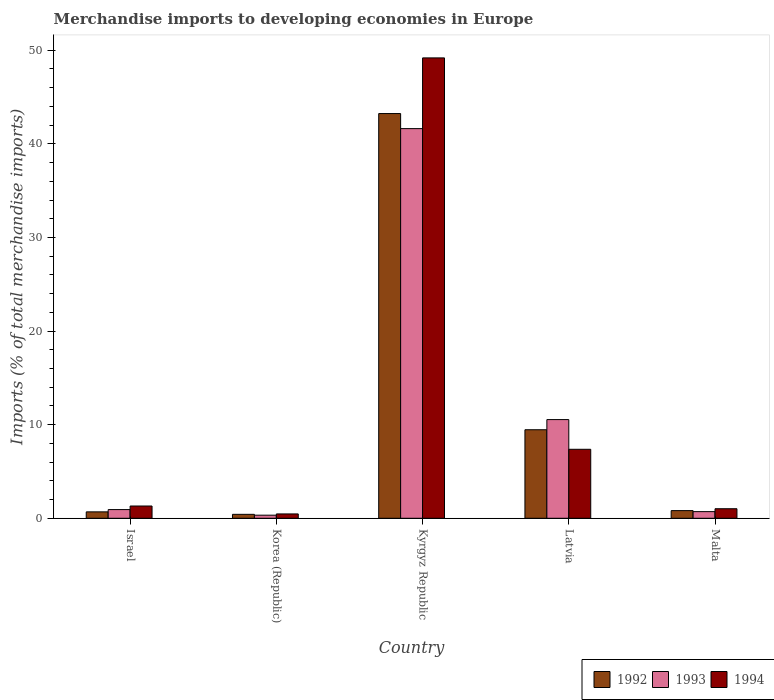How many different coloured bars are there?
Provide a short and direct response. 3. Are the number of bars per tick equal to the number of legend labels?
Your response must be concise. Yes. Are the number of bars on each tick of the X-axis equal?
Offer a terse response. Yes. How many bars are there on the 5th tick from the right?
Your answer should be very brief. 3. What is the label of the 3rd group of bars from the left?
Offer a very short reply. Kyrgyz Republic. What is the percentage total merchandise imports in 1993 in Kyrgyz Republic?
Offer a terse response. 41.63. Across all countries, what is the maximum percentage total merchandise imports in 1994?
Your answer should be very brief. 49.18. Across all countries, what is the minimum percentage total merchandise imports in 1994?
Ensure brevity in your answer.  0.46. In which country was the percentage total merchandise imports in 1994 maximum?
Ensure brevity in your answer.  Kyrgyz Republic. In which country was the percentage total merchandise imports in 1994 minimum?
Provide a short and direct response. Korea (Republic). What is the total percentage total merchandise imports in 1993 in the graph?
Ensure brevity in your answer.  54.14. What is the difference between the percentage total merchandise imports in 1993 in Korea (Republic) and that in Malta?
Offer a terse response. -0.38. What is the difference between the percentage total merchandise imports in 1994 in Malta and the percentage total merchandise imports in 1993 in Kyrgyz Republic?
Offer a terse response. -40.61. What is the average percentage total merchandise imports in 1992 per country?
Ensure brevity in your answer.  10.92. What is the difference between the percentage total merchandise imports of/in 1992 and percentage total merchandise imports of/in 1994 in Malta?
Make the answer very short. -0.2. What is the ratio of the percentage total merchandise imports in 1993 in Kyrgyz Republic to that in Latvia?
Your answer should be compact. 3.95. Is the difference between the percentage total merchandise imports in 1992 in Israel and Latvia greater than the difference between the percentage total merchandise imports in 1994 in Israel and Latvia?
Your response must be concise. No. What is the difference between the highest and the second highest percentage total merchandise imports in 1994?
Keep it short and to the point. 47.87. What is the difference between the highest and the lowest percentage total merchandise imports in 1992?
Offer a very short reply. 42.82. Is the sum of the percentage total merchandise imports in 1994 in Kyrgyz Republic and Latvia greater than the maximum percentage total merchandise imports in 1992 across all countries?
Offer a very short reply. Yes. What does the 3rd bar from the left in Latvia represents?
Make the answer very short. 1994. What does the 2nd bar from the right in Korea (Republic) represents?
Your response must be concise. 1993. Is it the case that in every country, the sum of the percentage total merchandise imports in 1994 and percentage total merchandise imports in 1992 is greater than the percentage total merchandise imports in 1993?
Provide a succinct answer. Yes. How many countries are there in the graph?
Keep it short and to the point. 5. What is the difference between two consecutive major ticks on the Y-axis?
Ensure brevity in your answer.  10. Does the graph contain any zero values?
Your answer should be compact. No. Does the graph contain grids?
Keep it short and to the point. No. How are the legend labels stacked?
Your response must be concise. Horizontal. What is the title of the graph?
Ensure brevity in your answer.  Merchandise imports to developing economies in Europe. Does "1967" appear as one of the legend labels in the graph?
Your answer should be compact. No. What is the label or title of the Y-axis?
Provide a succinct answer. Imports (% of total merchandise imports). What is the Imports (% of total merchandise imports) in 1992 in Israel?
Ensure brevity in your answer.  0.68. What is the Imports (% of total merchandise imports) in 1993 in Israel?
Offer a very short reply. 0.93. What is the Imports (% of total merchandise imports) in 1994 in Israel?
Your response must be concise. 1.31. What is the Imports (% of total merchandise imports) of 1992 in Korea (Republic)?
Keep it short and to the point. 0.42. What is the Imports (% of total merchandise imports) of 1993 in Korea (Republic)?
Your answer should be compact. 0.33. What is the Imports (% of total merchandise imports) of 1994 in Korea (Republic)?
Ensure brevity in your answer.  0.46. What is the Imports (% of total merchandise imports) of 1992 in Kyrgyz Republic?
Give a very brief answer. 43.24. What is the Imports (% of total merchandise imports) of 1993 in Kyrgyz Republic?
Provide a short and direct response. 41.63. What is the Imports (% of total merchandise imports) in 1994 in Kyrgyz Republic?
Keep it short and to the point. 49.18. What is the Imports (% of total merchandise imports) in 1992 in Latvia?
Make the answer very short. 9.46. What is the Imports (% of total merchandise imports) of 1993 in Latvia?
Your response must be concise. 10.54. What is the Imports (% of total merchandise imports) in 1994 in Latvia?
Ensure brevity in your answer.  7.37. What is the Imports (% of total merchandise imports) in 1992 in Malta?
Offer a very short reply. 0.82. What is the Imports (% of total merchandise imports) of 1993 in Malta?
Offer a terse response. 0.71. What is the Imports (% of total merchandise imports) of 1994 in Malta?
Provide a short and direct response. 1.02. Across all countries, what is the maximum Imports (% of total merchandise imports) of 1992?
Offer a very short reply. 43.24. Across all countries, what is the maximum Imports (% of total merchandise imports) in 1993?
Provide a succinct answer. 41.63. Across all countries, what is the maximum Imports (% of total merchandise imports) in 1994?
Provide a short and direct response. 49.18. Across all countries, what is the minimum Imports (% of total merchandise imports) in 1992?
Your answer should be compact. 0.42. Across all countries, what is the minimum Imports (% of total merchandise imports) in 1993?
Offer a terse response. 0.33. Across all countries, what is the minimum Imports (% of total merchandise imports) of 1994?
Keep it short and to the point. 0.46. What is the total Imports (% of total merchandise imports) in 1992 in the graph?
Provide a succinct answer. 54.62. What is the total Imports (% of total merchandise imports) of 1993 in the graph?
Offer a very short reply. 54.14. What is the total Imports (% of total merchandise imports) of 1994 in the graph?
Your answer should be compact. 59.35. What is the difference between the Imports (% of total merchandise imports) of 1992 in Israel and that in Korea (Republic)?
Offer a very short reply. 0.26. What is the difference between the Imports (% of total merchandise imports) in 1993 in Israel and that in Korea (Republic)?
Offer a very short reply. 0.6. What is the difference between the Imports (% of total merchandise imports) in 1994 in Israel and that in Korea (Republic)?
Provide a succinct answer. 0.85. What is the difference between the Imports (% of total merchandise imports) in 1992 in Israel and that in Kyrgyz Republic?
Your response must be concise. -42.55. What is the difference between the Imports (% of total merchandise imports) of 1993 in Israel and that in Kyrgyz Republic?
Your response must be concise. -40.7. What is the difference between the Imports (% of total merchandise imports) of 1994 in Israel and that in Kyrgyz Republic?
Offer a very short reply. -47.87. What is the difference between the Imports (% of total merchandise imports) of 1992 in Israel and that in Latvia?
Your answer should be very brief. -8.77. What is the difference between the Imports (% of total merchandise imports) in 1993 in Israel and that in Latvia?
Offer a very short reply. -9.62. What is the difference between the Imports (% of total merchandise imports) of 1994 in Israel and that in Latvia?
Keep it short and to the point. -6.06. What is the difference between the Imports (% of total merchandise imports) in 1992 in Israel and that in Malta?
Your answer should be very brief. -0.13. What is the difference between the Imports (% of total merchandise imports) of 1993 in Israel and that in Malta?
Your answer should be compact. 0.22. What is the difference between the Imports (% of total merchandise imports) of 1994 in Israel and that in Malta?
Provide a short and direct response. 0.29. What is the difference between the Imports (% of total merchandise imports) of 1992 in Korea (Republic) and that in Kyrgyz Republic?
Your answer should be compact. -42.82. What is the difference between the Imports (% of total merchandise imports) of 1993 in Korea (Republic) and that in Kyrgyz Republic?
Keep it short and to the point. -41.3. What is the difference between the Imports (% of total merchandise imports) of 1994 in Korea (Republic) and that in Kyrgyz Republic?
Your answer should be compact. -48.72. What is the difference between the Imports (% of total merchandise imports) of 1992 in Korea (Republic) and that in Latvia?
Your answer should be compact. -9.04. What is the difference between the Imports (% of total merchandise imports) of 1993 in Korea (Republic) and that in Latvia?
Offer a terse response. -10.21. What is the difference between the Imports (% of total merchandise imports) of 1994 in Korea (Republic) and that in Latvia?
Your response must be concise. -6.91. What is the difference between the Imports (% of total merchandise imports) in 1992 in Korea (Republic) and that in Malta?
Your response must be concise. -0.4. What is the difference between the Imports (% of total merchandise imports) in 1993 in Korea (Republic) and that in Malta?
Ensure brevity in your answer.  -0.38. What is the difference between the Imports (% of total merchandise imports) of 1994 in Korea (Republic) and that in Malta?
Give a very brief answer. -0.56. What is the difference between the Imports (% of total merchandise imports) in 1992 in Kyrgyz Republic and that in Latvia?
Your answer should be compact. 33.78. What is the difference between the Imports (% of total merchandise imports) of 1993 in Kyrgyz Republic and that in Latvia?
Offer a very short reply. 31.08. What is the difference between the Imports (% of total merchandise imports) in 1994 in Kyrgyz Republic and that in Latvia?
Offer a terse response. 41.81. What is the difference between the Imports (% of total merchandise imports) of 1992 in Kyrgyz Republic and that in Malta?
Give a very brief answer. 42.42. What is the difference between the Imports (% of total merchandise imports) of 1993 in Kyrgyz Republic and that in Malta?
Ensure brevity in your answer.  40.92. What is the difference between the Imports (% of total merchandise imports) in 1994 in Kyrgyz Republic and that in Malta?
Your answer should be very brief. 48.16. What is the difference between the Imports (% of total merchandise imports) in 1992 in Latvia and that in Malta?
Your response must be concise. 8.64. What is the difference between the Imports (% of total merchandise imports) of 1993 in Latvia and that in Malta?
Make the answer very short. 9.83. What is the difference between the Imports (% of total merchandise imports) of 1994 in Latvia and that in Malta?
Ensure brevity in your answer.  6.35. What is the difference between the Imports (% of total merchandise imports) in 1992 in Israel and the Imports (% of total merchandise imports) in 1993 in Korea (Republic)?
Offer a very short reply. 0.35. What is the difference between the Imports (% of total merchandise imports) of 1992 in Israel and the Imports (% of total merchandise imports) of 1994 in Korea (Republic)?
Offer a terse response. 0.22. What is the difference between the Imports (% of total merchandise imports) in 1993 in Israel and the Imports (% of total merchandise imports) in 1994 in Korea (Republic)?
Provide a short and direct response. 0.46. What is the difference between the Imports (% of total merchandise imports) in 1992 in Israel and the Imports (% of total merchandise imports) in 1993 in Kyrgyz Republic?
Give a very brief answer. -40.94. What is the difference between the Imports (% of total merchandise imports) in 1992 in Israel and the Imports (% of total merchandise imports) in 1994 in Kyrgyz Republic?
Give a very brief answer. -48.5. What is the difference between the Imports (% of total merchandise imports) in 1993 in Israel and the Imports (% of total merchandise imports) in 1994 in Kyrgyz Republic?
Ensure brevity in your answer.  -48.26. What is the difference between the Imports (% of total merchandise imports) in 1992 in Israel and the Imports (% of total merchandise imports) in 1993 in Latvia?
Keep it short and to the point. -9.86. What is the difference between the Imports (% of total merchandise imports) in 1992 in Israel and the Imports (% of total merchandise imports) in 1994 in Latvia?
Ensure brevity in your answer.  -6.69. What is the difference between the Imports (% of total merchandise imports) of 1993 in Israel and the Imports (% of total merchandise imports) of 1994 in Latvia?
Provide a short and direct response. -6.44. What is the difference between the Imports (% of total merchandise imports) in 1992 in Israel and the Imports (% of total merchandise imports) in 1993 in Malta?
Your response must be concise. -0.02. What is the difference between the Imports (% of total merchandise imports) of 1992 in Israel and the Imports (% of total merchandise imports) of 1994 in Malta?
Provide a short and direct response. -0.34. What is the difference between the Imports (% of total merchandise imports) of 1993 in Israel and the Imports (% of total merchandise imports) of 1994 in Malta?
Your answer should be very brief. -0.09. What is the difference between the Imports (% of total merchandise imports) of 1992 in Korea (Republic) and the Imports (% of total merchandise imports) of 1993 in Kyrgyz Republic?
Offer a terse response. -41.21. What is the difference between the Imports (% of total merchandise imports) of 1992 in Korea (Republic) and the Imports (% of total merchandise imports) of 1994 in Kyrgyz Republic?
Your response must be concise. -48.76. What is the difference between the Imports (% of total merchandise imports) of 1993 in Korea (Republic) and the Imports (% of total merchandise imports) of 1994 in Kyrgyz Republic?
Offer a terse response. -48.85. What is the difference between the Imports (% of total merchandise imports) in 1992 in Korea (Republic) and the Imports (% of total merchandise imports) in 1993 in Latvia?
Provide a succinct answer. -10.12. What is the difference between the Imports (% of total merchandise imports) of 1992 in Korea (Republic) and the Imports (% of total merchandise imports) of 1994 in Latvia?
Your answer should be compact. -6.95. What is the difference between the Imports (% of total merchandise imports) of 1993 in Korea (Republic) and the Imports (% of total merchandise imports) of 1994 in Latvia?
Your answer should be compact. -7.04. What is the difference between the Imports (% of total merchandise imports) in 1992 in Korea (Republic) and the Imports (% of total merchandise imports) in 1993 in Malta?
Your answer should be compact. -0.29. What is the difference between the Imports (% of total merchandise imports) of 1992 in Korea (Republic) and the Imports (% of total merchandise imports) of 1994 in Malta?
Ensure brevity in your answer.  -0.6. What is the difference between the Imports (% of total merchandise imports) of 1993 in Korea (Republic) and the Imports (% of total merchandise imports) of 1994 in Malta?
Your answer should be very brief. -0.69. What is the difference between the Imports (% of total merchandise imports) in 1992 in Kyrgyz Republic and the Imports (% of total merchandise imports) in 1993 in Latvia?
Your answer should be compact. 32.69. What is the difference between the Imports (% of total merchandise imports) in 1992 in Kyrgyz Republic and the Imports (% of total merchandise imports) in 1994 in Latvia?
Your answer should be compact. 35.87. What is the difference between the Imports (% of total merchandise imports) of 1993 in Kyrgyz Republic and the Imports (% of total merchandise imports) of 1994 in Latvia?
Your answer should be compact. 34.26. What is the difference between the Imports (% of total merchandise imports) in 1992 in Kyrgyz Republic and the Imports (% of total merchandise imports) in 1993 in Malta?
Your response must be concise. 42.53. What is the difference between the Imports (% of total merchandise imports) in 1992 in Kyrgyz Republic and the Imports (% of total merchandise imports) in 1994 in Malta?
Keep it short and to the point. 42.22. What is the difference between the Imports (% of total merchandise imports) in 1993 in Kyrgyz Republic and the Imports (% of total merchandise imports) in 1994 in Malta?
Keep it short and to the point. 40.61. What is the difference between the Imports (% of total merchandise imports) of 1992 in Latvia and the Imports (% of total merchandise imports) of 1993 in Malta?
Provide a short and direct response. 8.75. What is the difference between the Imports (% of total merchandise imports) in 1992 in Latvia and the Imports (% of total merchandise imports) in 1994 in Malta?
Make the answer very short. 8.44. What is the difference between the Imports (% of total merchandise imports) of 1993 in Latvia and the Imports (% of total merchandise imports) of 1994 in Malta?
Your response must be concise. 9.52. What is the average Imports (% of total merchandise imports) in 1992 per country?
Ensure brevity in your answer.  10.92. What is the average Imports (% of total merchandise imports) of 1993 per country?
Give a very brief answer. 10.83. What is the average Imports (% of total merchandise imports) in 1994 per country?
Keep it short and to the point. 11.87. What is the difference between the Imports (% of total merchandise imports) in 1992 and Imports (% of total merchandise imports) in 1993 in Israel?
Make the answer very short. -0.24. What is the difference between the Imports (% of total merchandise imports) of 1992 and Imports (% of total merchandise imports) of 1994 in Israel?
Your answer should be very brief. -0.62. What is the difference between the Imports (% of total merchandise imports) in 1993 and Imports (% of total merchandise imports) in 1994 in Israel?
Provide a succinct answer. -0.38. What is the difference between the Imports (% of total merchandise imports) in 1992 and Imports (% of total merchandise imports) in 1993 in Korea (Republic)?
Give a very brief answer. 0.09. What is the difference between the Imports (% of total merchandise imports) of 1992 and Imports (% of total merchandise imports) of 1994 in Korea (Republic)?
Offer a terse response. -0.04. What is the difference between the Imports (% of total merchandise imports) of 1993 and Imports (% of total merchandise imports) of 1994 in Korea (Republic)?
Your response must be concise. -0.13. What is the difference between the Imports (% of total merchandise imports) in 1992 and Imports (% of total merchandise imports) in 1993 in Kyrgyz Republic?
Ensure brevity in your answer.  1.61. What is the difference between the Imports (% of total merchandise imports) of 1992 and Imports (% of total merchandise imports) of 1994 in Kyrgyz Republic?
Your answer should be compact. -5.95. What is the difference between the Imports (% of total merchandise imports) in 1993 and Imports (% of total merchandise imports) in 1994 in Kyrgyz Republic?
Give a very brief answer. -7.56. What is the difference between the Imports (% of total merchandise imports) of 1992 and Imports (% of total merchandise imports) of 1993 in Latvia?
Your answer should be very brief. -1.09. What is the difference between the Imports (% of total merchandise imports) of 1992 and Imports (% of total merchandise imports) of 1994 in Latvia?
Offer a terse response. 2.09. What is the difference between the Imports (% of total merchandise imports) of 1993 and Imports (% of total merchandise imports) of 1994 in Latvia?
Provide a short and direct response. 3.17. What is the difference between the Imports (% of total merchandise imports) in 1992 and Imports (% of total merchandise imports) in 1993 in Malta?
Keep it short and to the point. 0.11. What is the difference between the Imports (% of total merchandise imports) in 1992 and Imports (% of total merchandise imports) in 1994 in Malta?
Provide a succinct answer. -0.2. What is the difference between the Imports (% of total merchandise imports) in 1993 and Imports (% of total merchandise imports) in 1994 in Malta?
Your answer should be very brief. -0.31. What is the ratio of the Imports (% of total merchandise imports) in 1992 in Israel to that in Korea (Republic)?
Provide a short and direct response. 1.63. What is the ratio of the Imports (% of total merchandise imports) of 1993 in Israel to that in Korea (Republic)?
Your response must be concise. 2.81. What is the ratio of the Imports (% of total merchandise imports) of 1994 in Israel to that in Korea (Republic)?
Offer a terse response. 2.83. What is the ratio of the Imports (% of total merchandise imports) in 1992 in Israel to that in Kyrgyz Republic?
Give a very brief answer. 0.02. What is the ratio of the Imports (% of total merchandise imports) in 1993 in Israel to that in Kyrgyz Republic?
Offer a very short reply. 0.02. What is the ratio of the Imports (% of total merchandise imports) in 1994 in Israel to that in Kyrgyz Republic?
Make the answer very short. 0.03. What is the ratio of the Imports (% of total merchandise imports) in 1992 in Israel to that in Latvia?
Your answer should be compact. 0.07. What is the ratio of the Imports (% of total merchandise imports) in 1993 in Israel to that in Latvia?
Your response must be concise. 0.09. What is the ratio of the Imports (% of total merchandise imports) of 1994 in Israel to that in Latvia?
Make the answer very short. 0.18. What is the ratio of the Imports (% of total merchandise imports) in 1992 in Israel to that in Malta?
Provide a succinct answer. 0.84. What is the ratio of the Imports (% of total merchandise imports) of 1993 in Israel to that in Malta?
Provide a succinct answer. 1.31. What is the ratio of the Imports (% of total merchandise imports) of 1994 in Israel to that in Malta?
Provide a short and direct response. 1.28. What is the ratio of the Imports (% of total merchandise imports) in 1992 in Korea (Republic) to that in Kyrgyz Republic?
Offer a terse response. 0.01. What is the ratio of the Imports (% of total merchandise imports) of 1993 in Korea (Republic) to that in Kyrgyz Republic?
Your answer should be very brief. 0.01. What is the ratio of the Imports (% of total merchandise imports) of 1994 in Korea (Republic) to that in Kyrgyz Republic?
Your answer should be compact. 0.01. What is the ratio of the Imports (% of total merchandise imports) of 1992 in Korea (Republic) to that in Latvia?
Ensure brevity in your answer.  0.04. What is the ratio of the Imports (% of total merchandise imports) of 1993 in Korea (Republic) to that in Latvia?
Your response must be concise. 0.03. What is the ratio of the Imports (% of total merchandise imports) of 1994 in Korea (Republic) to that in Latvia?
Give a very brief answer. 0.06. What is the ratio of the Imports (% of total merchandise imports) of 1992 in Korea (Republic) to that in Malta?
Offer a very short reply. 0.51. What is the ratio of the Imports (% of total merchandise imports) of 1993 in Korea (Republic) to that in Malta?
Your answer should be compact. 0.47. What is the ratio of the Imports (% of total merchandise imports) of 1994 in Korea (Republic) to that in Malta?
Provide a short and direct response. 0.45. What is the ratio of the Imports (% of total merchandise imports) of 1992 in Kyrgyz Republic to that in Latvia?
Offer a terse response. 4.57. What is the ratio of the Imports (% of total merchandise imports) of 1993 in Kyrgyz Republic to that in Latvia?
Provide a short and direct response. 3.95. What is the ratio of the Imports (% of total merchandise imports) in 1994 in Kyrgyz Republic to that in Latvia?
Keep it short and to the point. 6.67. What is the ratio of the Imports (% of total merchandise imports) in 1992 in Kyrgyz Republic to that in Malta?
Your answer should be compact. 52.87. What is the ratio of the Imports (% of total merchandise imports) in 1993 in Kyrgyz Republic to that in Malta?
Keep it short and to the point. 58.77. What is the ratio of the Imports (% of total merchandise imports) of 1994 in Kyrgyz Republic to that in Malta?
Offer a terse response. 48.22. What is the ratio of the Imports (% of total merchandise imports) of 1992 in Latvia to that in Malta?
Make the answer very short. 11.56. What is the ratio of the Imports (% of total merchandise imports) of 1993 in Latvia to that in Malta?
Offer a terse response. 14.88. What is the ratio of the Imports (% of total merchandise imports) in 1994 in Latvia to that in Malta?
Your answer should be very brief. 7.23. What is the difference between the highest and the second highest Imports (% of total merchandise imports) in 1992?
Provide a succinct answer. 33.78. What is the difference between the highest and the second highest Imports (% of total merchandise imports) in 1993?
Ensure brevity in your answer.  31.08. What is the difference between the highest and the second highest Imports (% of total merchandise imports) of 1994?
Make the answer very short. 41.81. What is the difference between the highest and the lowest Imports (% of total merchandise imports) in 1992?
Provide a succinct answer. 42.82. What is the difference between the highest and the lowest Imports (% of total merchandise imports) of 1993?
Give a very brief answer. 41.3. What is the difference between the highest and the lowest Imports (% of total merchandise imports) in 1994?
Offer a very short reply. 48.72. 